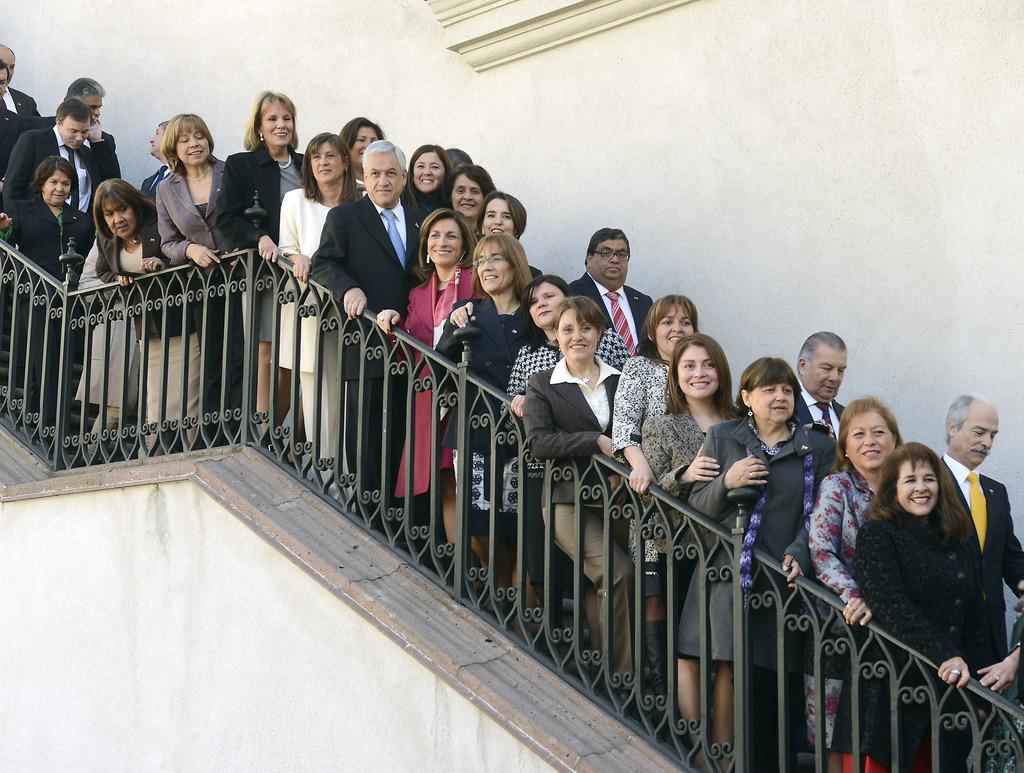In one or two sentences, can you explain what this image depicts? In this picture I can observe some people standing on the staircase. There are men and women in this picture. Beside them I can observe railing. In the background I can observe wall. 